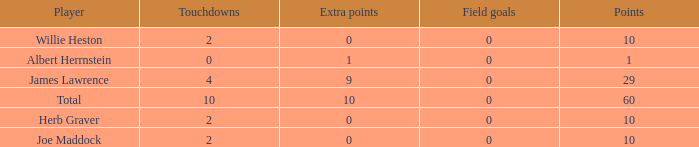I'm looking to parse the entire table for insights. Could you assist me with that? {'header': ['Player', 'Touchdowns', 'Extra points', 'Field goals', 'Points'], 'rows': [['Willie Heston', '2', '0', '0', '10'], ['Albert Herrnstein', '0', '1', '0', '1'], ['James Lawrence', '4', '9', '0', '29'], ['Total', '10', '10', '0', '60'], ['Herb Graver', '2', '0', '0', '10'], ['Joe Maddock', '2', '0', '0', '10']]} What is the average number of field goals for players with more than 60 points? None. 